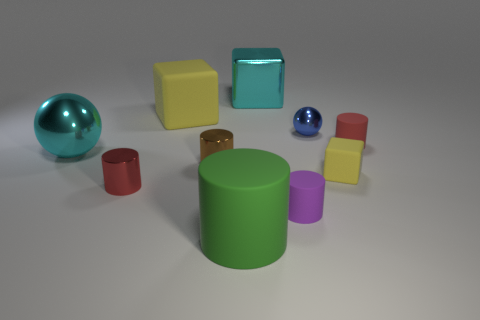How many yellow objects have the same shape as the red metal thing?
Make the answer very short. 0. What is the size of the cyan block that is the same material as the tiny brown object?
Ensure brevity in your answer.  Large. Is there a tiny red cylinder that is behind the small red cylinder that is on the left side of the cyan metallic block behind the big yellow matte object?
Give a very brief answer. Yes. Is the size of the blue metal thing right of the cyan metal block the same as the brown metal cylinder?
Make the answer very short. Yes. What number of blue balls have the same size as the shiny block?
Make the answer very short. 0. What size is the object that is the same color as the small matte cube?
Your answer should be very brief. Large. Is the big shiny block the same color as the big sphere?
Make the answer very short. Yes. There is a green object; what shape is it?
Make the answer very short. Cylinder. Are there any large spheres of the same color as the shiny block?
Your response must be concise. Yes. Are there more tiny matte things that are in front of the brown metallic cylinder than large green matte blocks?
Offer a terse response. Yes. 